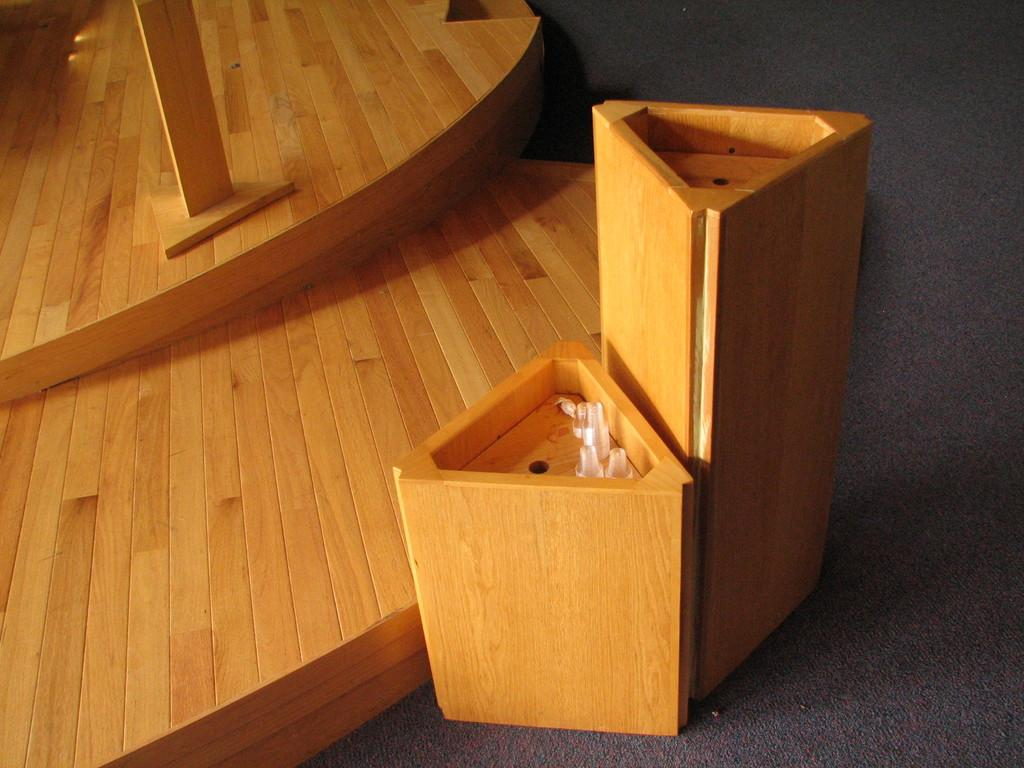What type of material are the objects in the image made of? The objects in the image are made of wood. Where are the wooden objects located in the image? The wooden objects are placed on the floor. What type of pain can be seen on the faces of the wooden objects in the image? There are no faces or expressions on the wooden objects in the image, so it is not possible to determine if they are experiencing any pain. 